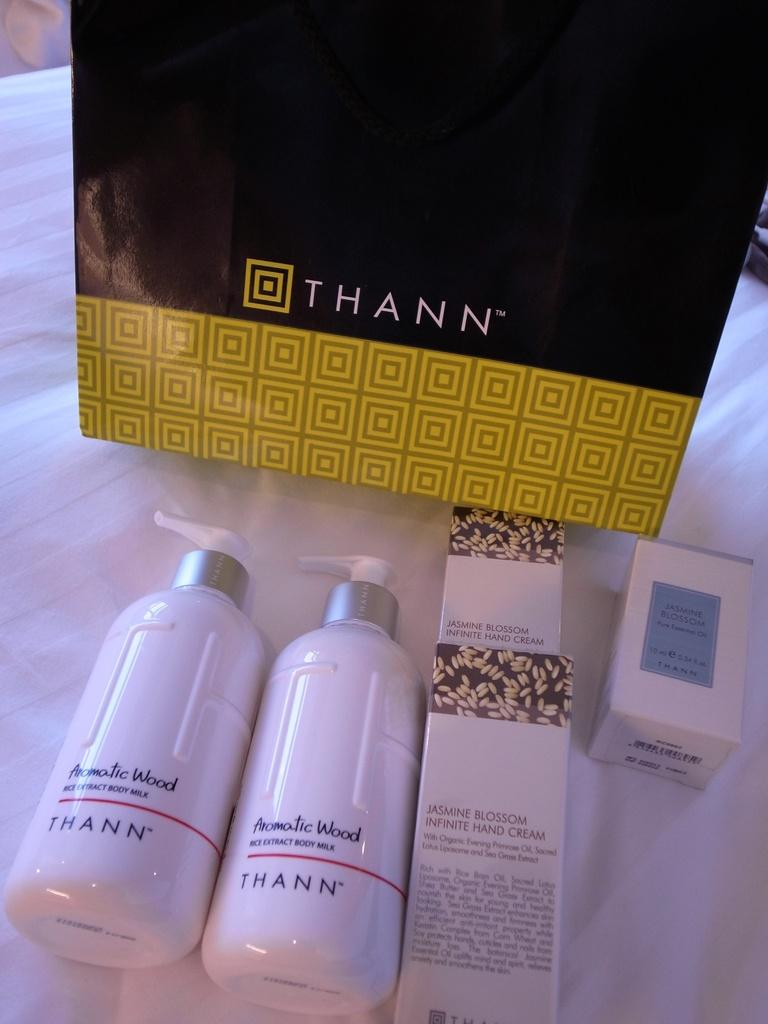<image>
Render a clear and concise summary of the photo. a collection of Thann body care products on a white background 